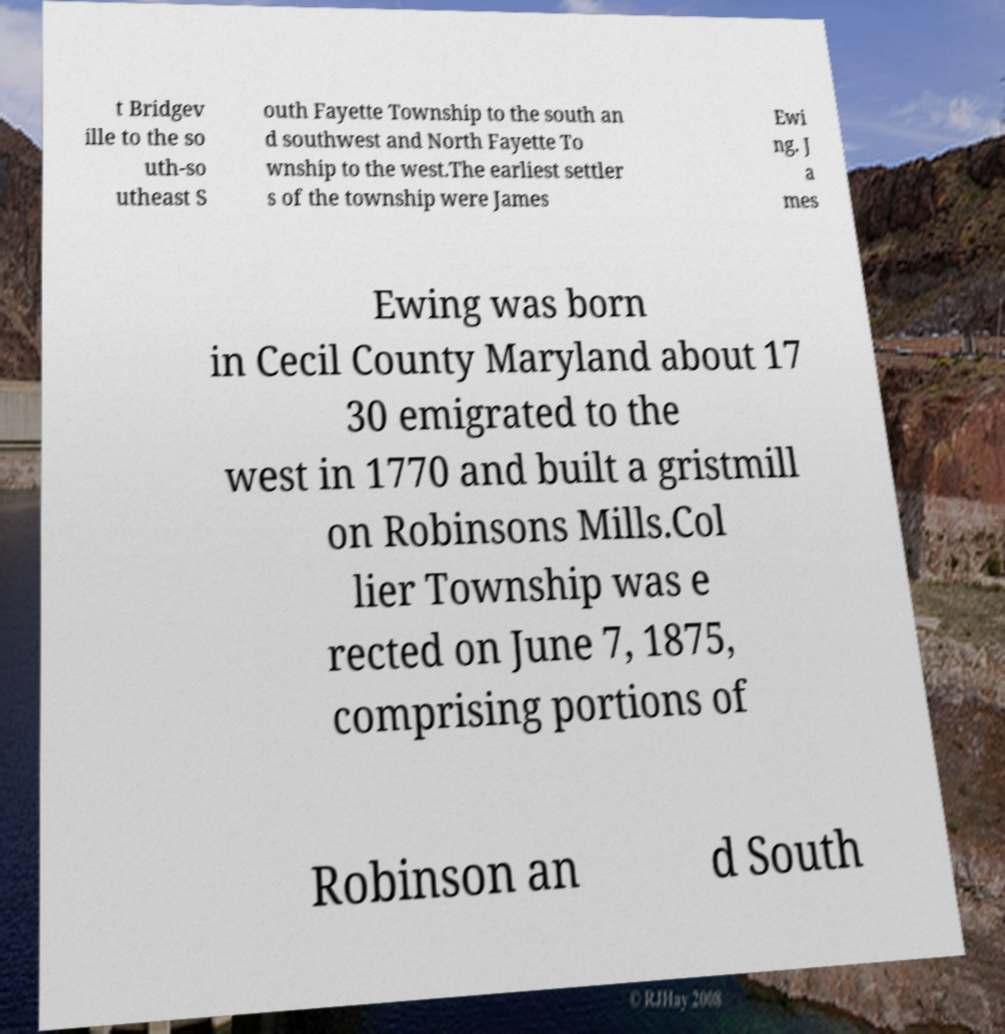Please read and relay the text visible in this image. What does it say? t Bridgev ille to the so uth-so utheast S outh Fayette Township to the south an d southwest and North Fayette To wnship to the west.The earliest settler s of the township were James Ewi ng. J a mes Ewing was born in Cecil County Maryland about 17 30 emigrated to the west in 1770 and built a gristmill on Robinsons Mills.Col lier Township was e rected on June 7, 1875, comprising portions of Robinson an d South 